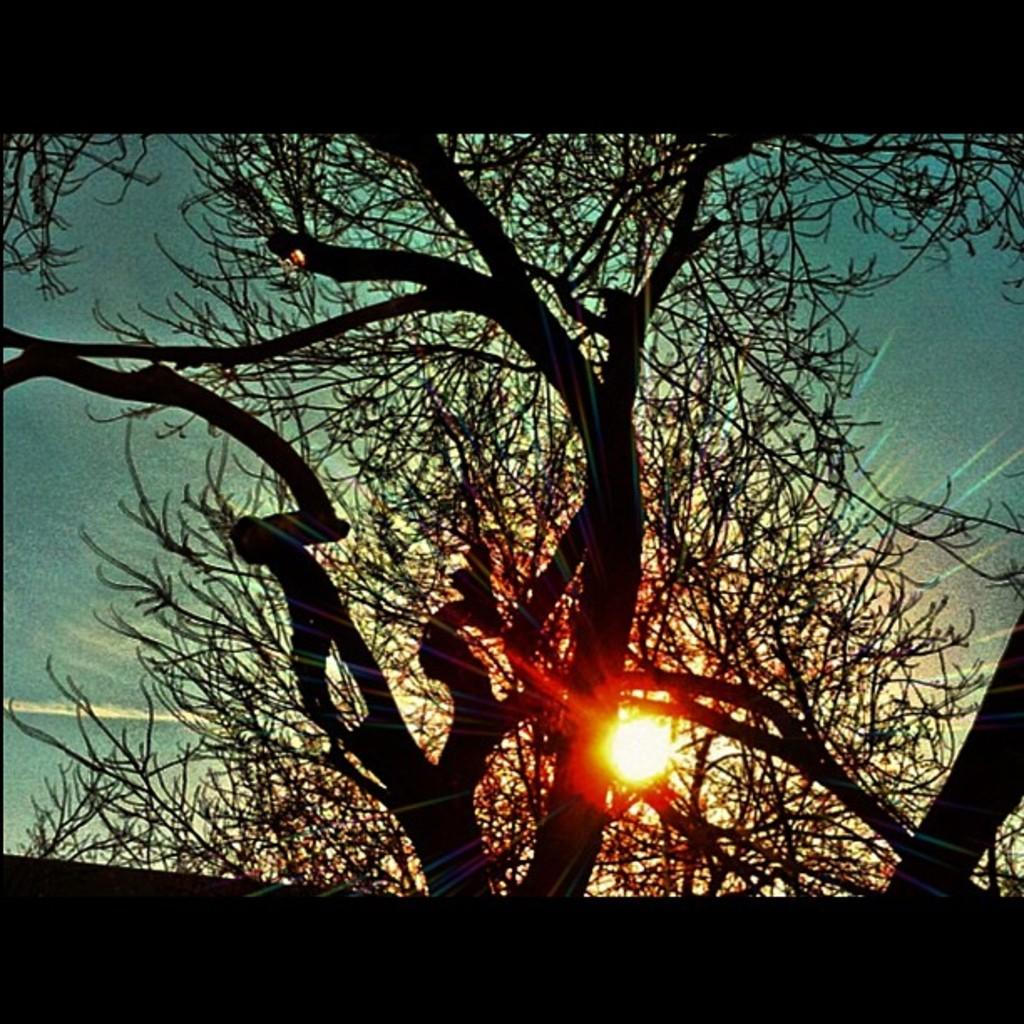What is the setting of the image? The image has an outside view. What can be seen in the foreground of the image? There is a tree in the foreground of the image. What is visible in the background of the image? The sky is visible in the background of the image. Where is the sun located in the image? The sun is present at the bottom of the image. Can you tell me how many wrens are perched on the tree in the image? There are no wrens present in the image; only a tree is visible in the foreground. How does the sun touch the tree in the image? The sun is not physically touching the tree in the image; it is merely visible at the bottom of the image. 